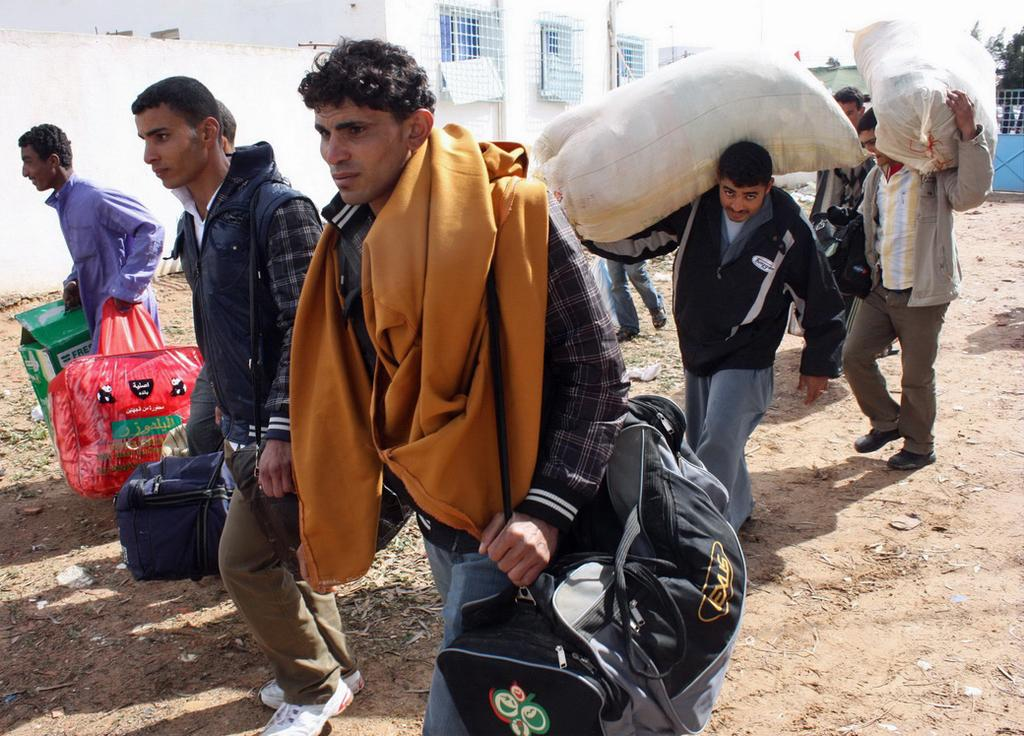What is the activity being performed by the men in the image? The men in the image are walking on the ground. What are the men carrying in their hands? The men are holding bags, cardboard cartons, and polythene sacks. What can be seen in the background of the image? There are buildings, grills, and trees in the background of the image. What type of organization is represented by the sock in the image? There is no sock present in the image, so it is not possible to determine any organization related to it. 